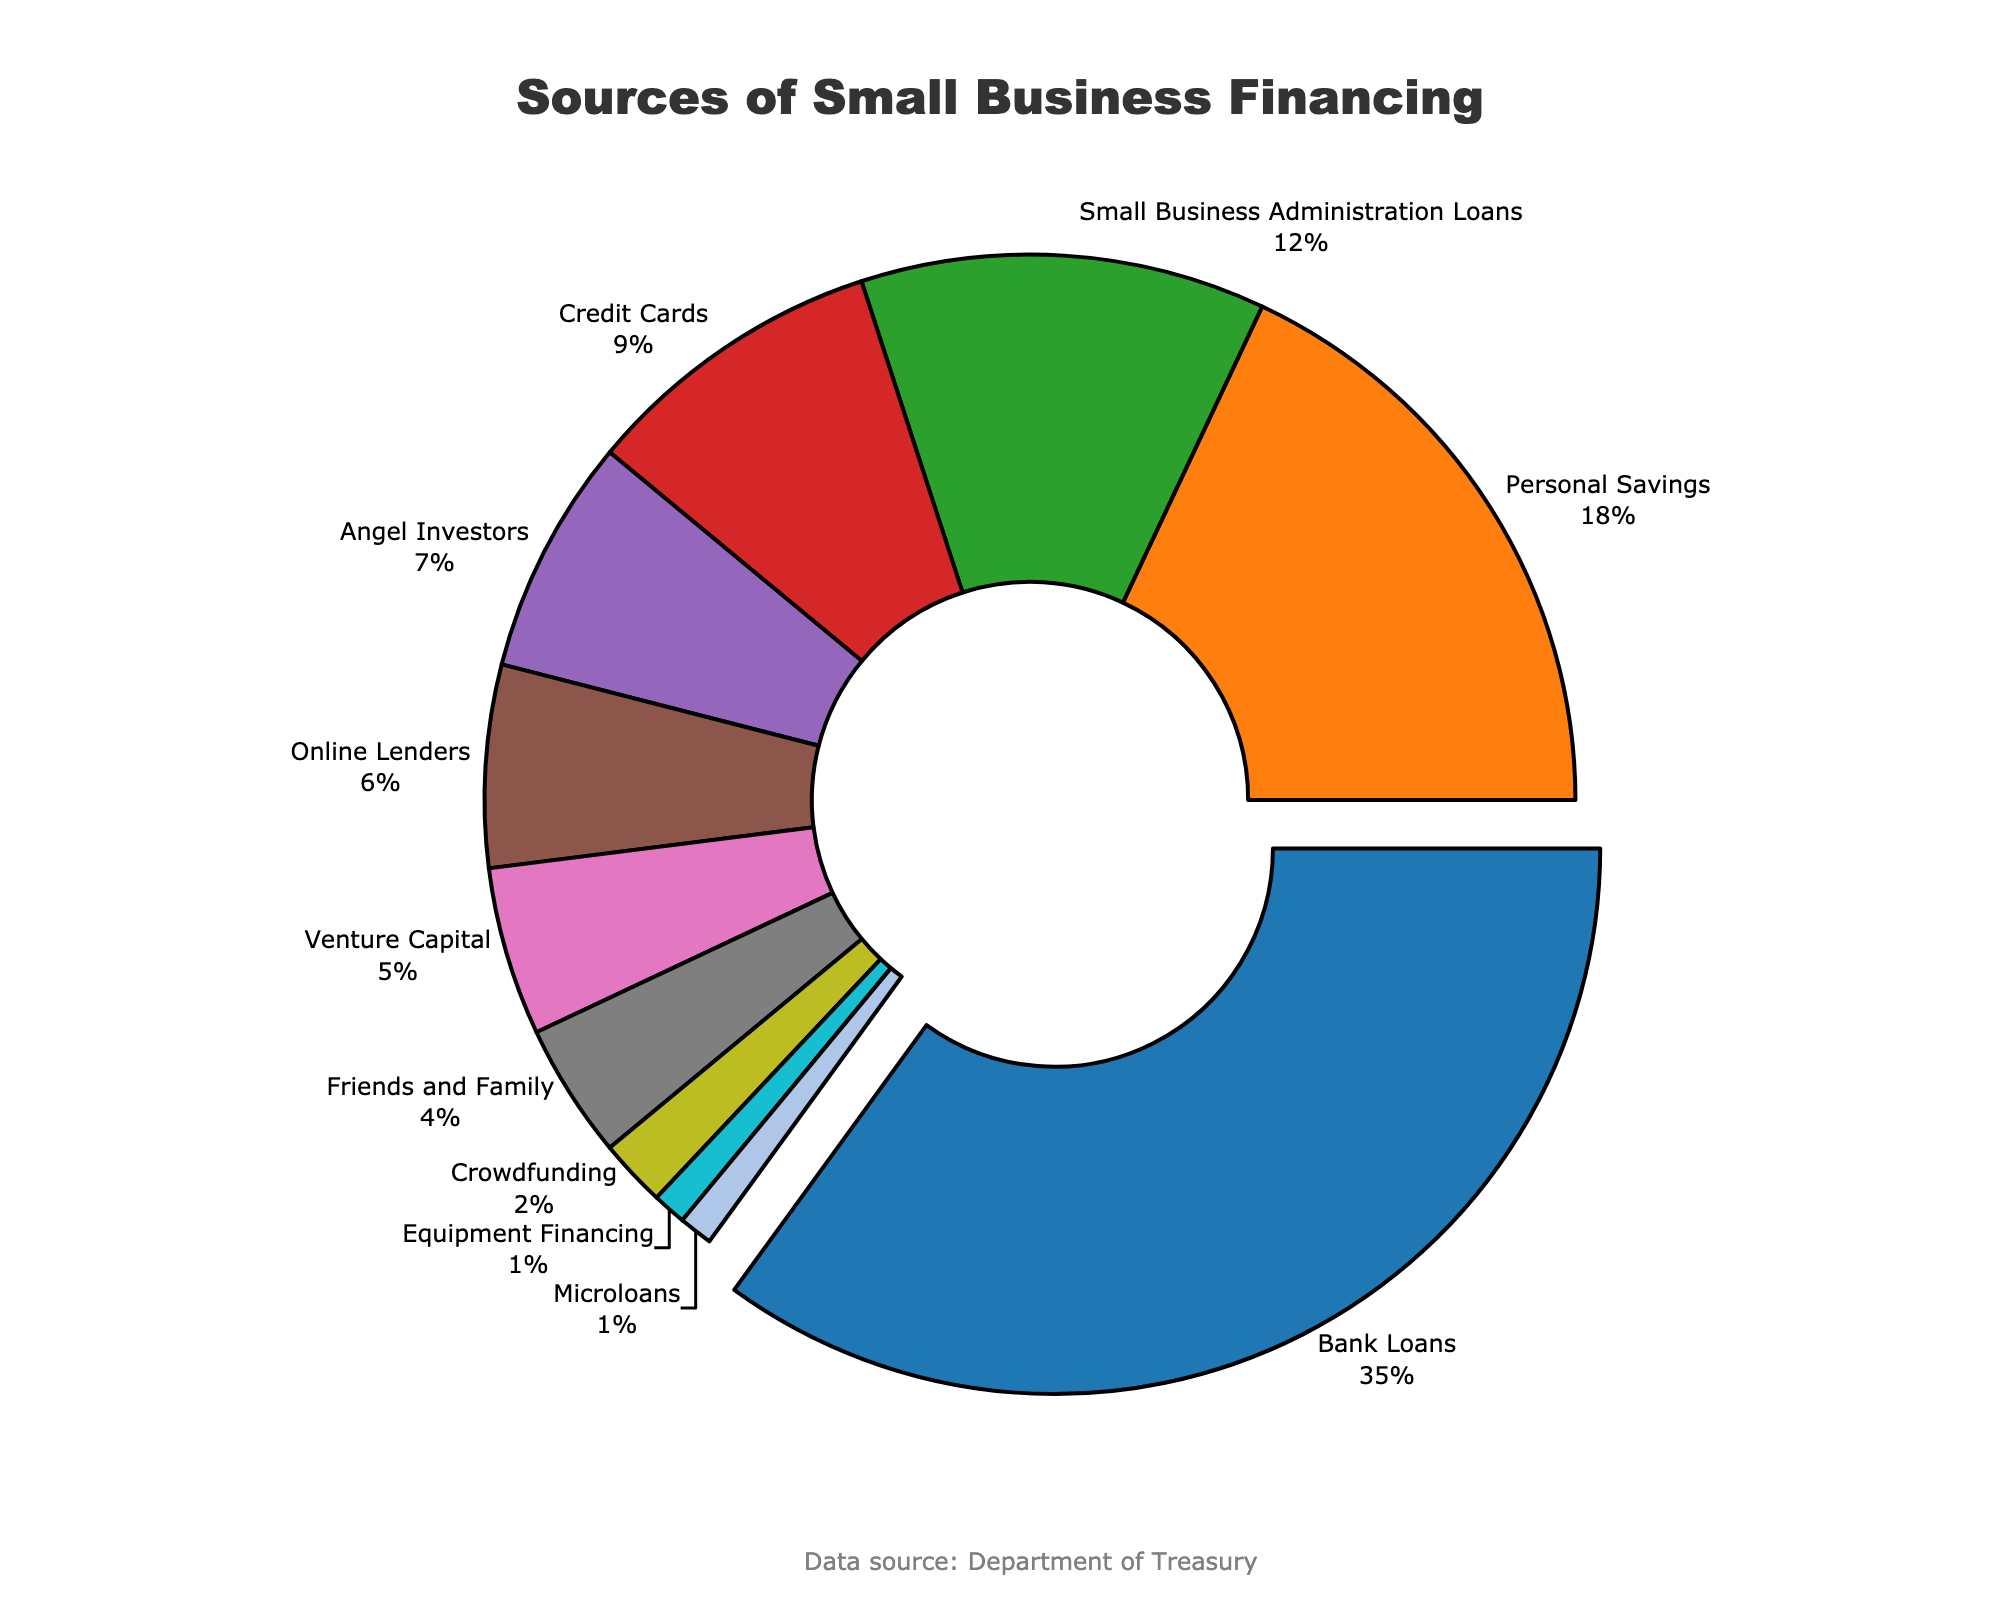What is the largest source of financing for small businesses? The largest segment is pulled out from the pie chart and labeled with "Bank Loans" accounting for 35%.
Answer: Bank Loans What proportion of financing comes from personal savings and credit cards combined? Find the segments labeled "Personal Savings" (18%) and "Credit Cards" (9%) and add their percentages together: 18% + 9% = 27%.
Answer: 27% How do Small Business Administration Loans compare to Angel Investors in terms of percentage? Locate the segments for "Small Business Administration Loans" (12%) and "Angel Investors" (7%) and see that SBA Loans (12%) are greater than Angel Investors (7%).
Answer: Small Business Administration Loans > Angel Investors Which sources of financing contribute the least to small businesses? Identify the smallest segments which are labeled "Equipment Financing" (1%) and "Microloans" (1%).
Answer: Equipment Financing and Microloans What is the total percentage of financing from sources outside of traditional investor types (e.g., excluding Angel Investors and Venture Capital)? Exclude the percentages for "Angel Investors" (7%) and "Venture Capital" (5%) and sum the rest: 35% + 18% + 12% + 9% + 6% + 4% + 2% + 1% + 1% = 88%.
Answer: 88% Is the percentage of financing from friends and family higher than from crowdfunding? Compare the segments labeled "Friends and Family" (4%) and "Crowdfunding" (2%). Friends and Family (4%) is greater than Crowdfunding (2%).
Answer: Yes What percentage of financing do sources outside of loans and personal savings contribute? Exclude "Bank Loans" (35%), "Personal Savings" (18%), "Small Business Administration Loans" (12%) and sum the rest: 9% + 7% + 6% + 5% + 4% + 2% + 1% + 1% = 35%.
Answer: 35% What financing sources contribute more than 5% but less than 10%? Identify the segments falling between 5% and 10%, specifically "Credit Cards" at 9%, "Angel Investors" at 7%, and "Online Lenders" at 6%.
Answer: Credit Cards, Angel Investors, and Online Lenders What is the difference in the percentage between the highest and lowest sources of financing? Subtract the smallest percentage, which is 1% (either Equipment Financing or Microloans), from the largest percentage, which is 35% (Bank Loans): 35% - 1% = 34%.
Answer: 34% 